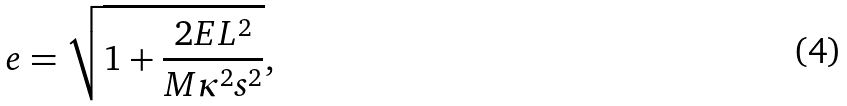Convert formula to latex. <formula><loc_0><loc_0><loc_500><loc_500>e = \sqrt { 1 + \frac { 2 E L ^ { 2 } } { M \kappa ^ { 2 } s ^ { 2 } } } ,</formula> 